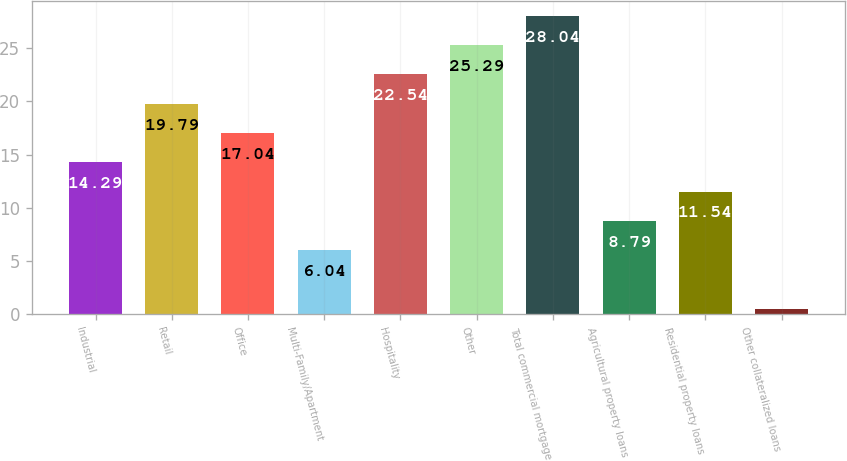Convert chart to OTSL. <chart><loc_0><loc_0><loc_500><loc_500><bar_chart><fcel>Industrial<fcel>Retail<fcel>Office<fcel>Multi-Family/Apartment<fcel>Hospitality<fcel>Other<fcel>Total commercial mortgage<fcel>Agricultural property loans<fcel>Residential property loans<fcel>Other collateralized loans<nl><fcel>14.29<fcel>19.79<fcel>17.04<fcel>6.04<fcel>22.54<fcel>25.29<fcel>28.04<fcel>8.79<fcel>11.54<fcel>0.54<nl></chart> 